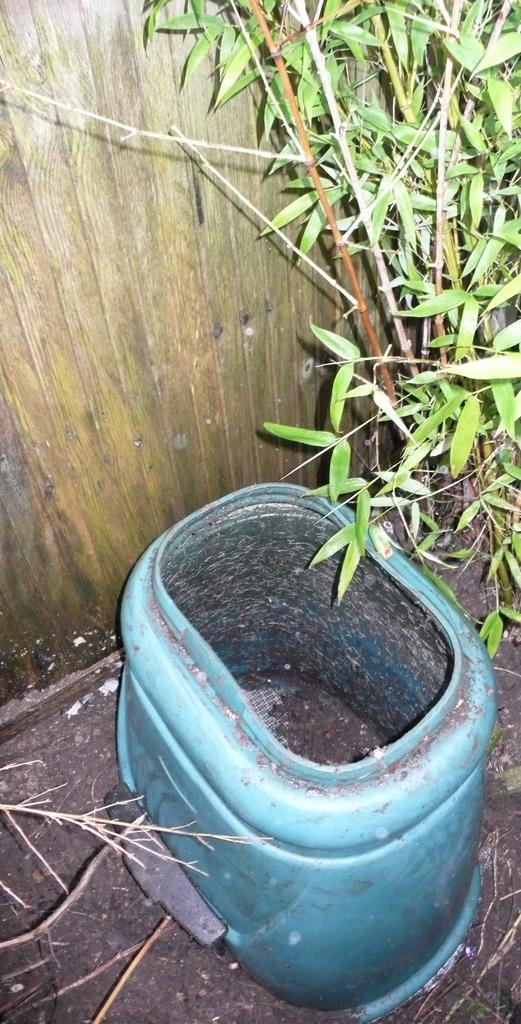What object is located at the bottom of the image? There is a plastic box at the bottom of the image. What type of vegetation can be seen on the right side of the image? There are trees on the right side of the image. What type of wall is visible in the background of the image? There is a wooden wall visible in the background of the image. What type of poison is being used to cause the trees to grow in the image? There is no mention of poison or any cause for the trees' growth in the image. The trees are simply present in the image. 